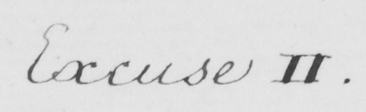Please transcribe the handwritten text in this image. Excuse II . 